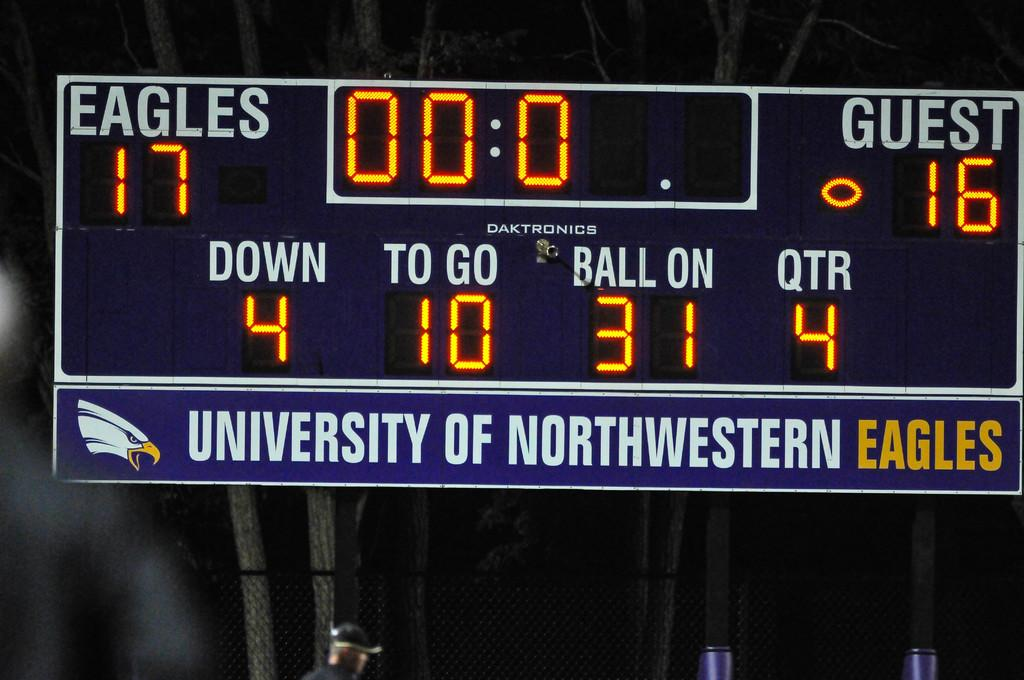<image>
Describe the image concisely. The University of Northwestern Eagles scoreboard shows that score as Eagles 17, Guest 16 in the 4th Quarter. 